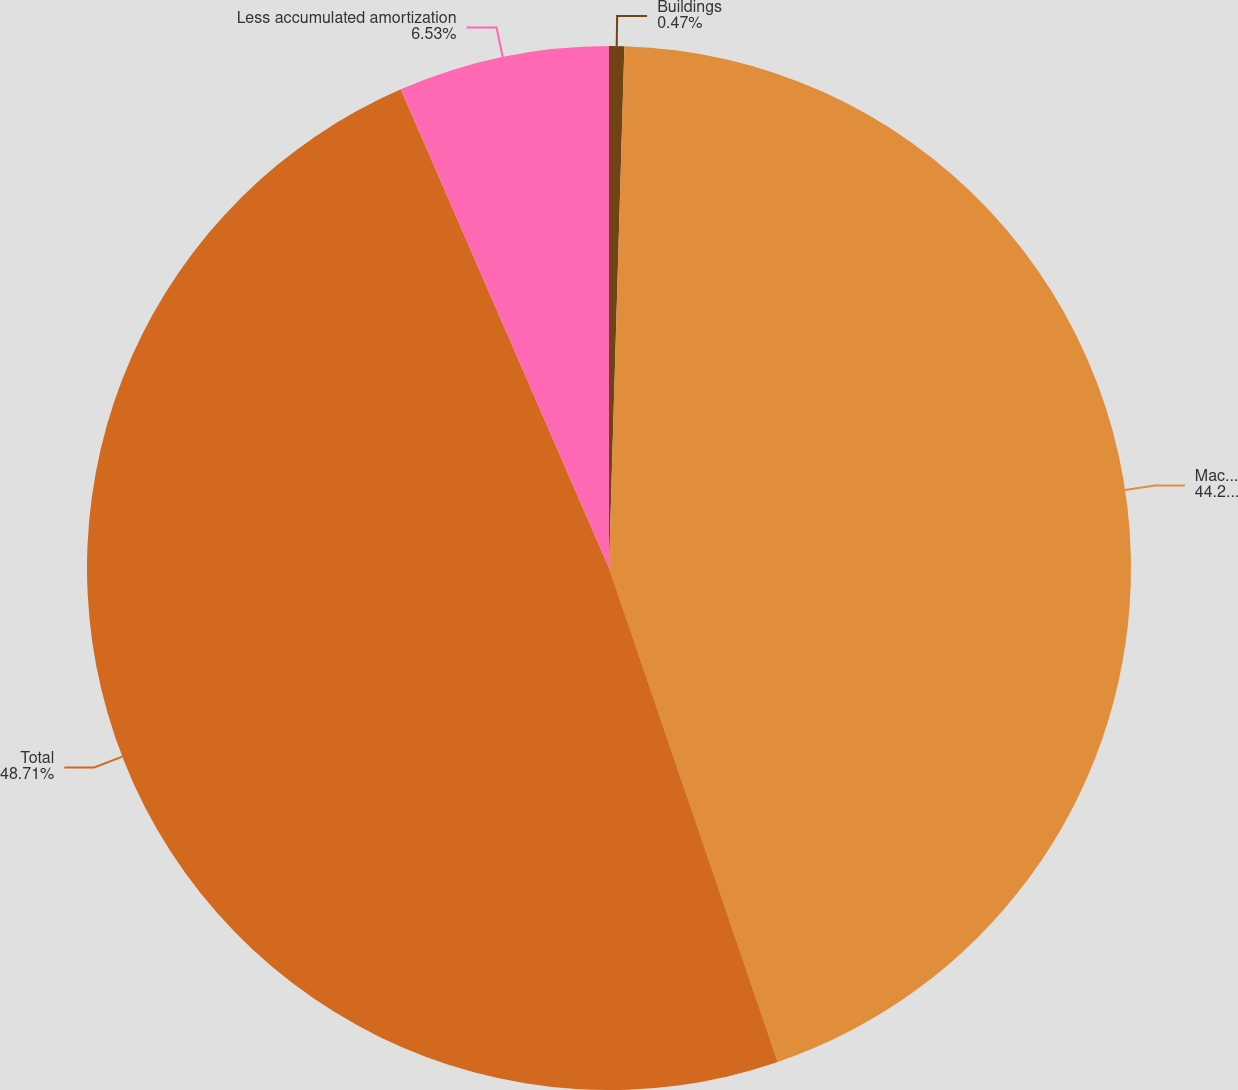<chart> <loc_0><loc_0><loc_500><loc_500><pie_chart><fcel>Buildings<fcel>Machinery and equipment<fcel>Total<fcel>Less accumulated amortization<nl><fcel>0.47%<fcel>44.29%<fcel>48.71%<fcel>6.53%<nl></chart> 